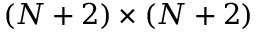Convert formula to latex. <formula><loc_0><loc_0><loc_500><loc_500>( N + 2 ) \times ( N + 2 )</formula> 